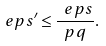Convert formula to latex. <formula><loc_0><loc_0><loc_500><loc_500>\ e p s ^ { \prime } \leq \frac { \ e p s } { p q } .</formula> 